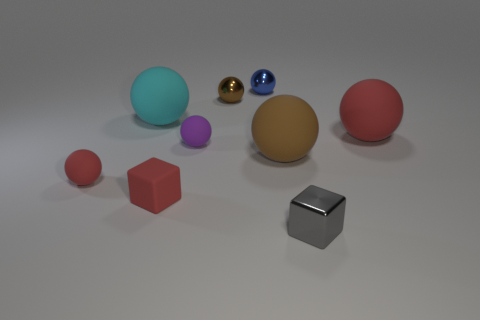There is a tiny red ball; are there any big red balls on the left side of it?
Provide a succinct answer. No. Is the number of small rubber objects that are behind the tiny brown sphere greater than the number of large red rubber objects that are left of the big cyan ball?
Provide a short and direct response. No. There is a cyan matte thing that is the same shape as the blue metallic thing; what size is it?
Offer a terse response. Large. What number of cylinders are rubber things or tiny blue things?
Your answer should be compact. 0. What is the material of the tiny thing that is the same color as the small matte block?
Give a very brief answer. Rubber. Are there fewer small purple spheres that are to the right of the small gray cube than matte blocks behind the red matte cube?
Your answer should be compact. No. How many things are tiny purple objects that are on the left side of the tiny blue ball or large cyan rubber cylinders?
Provide a short and direct response. 1. What is the shape of the large matte object that is behind the red rubber object on the right side of the large brown sphere?
Your response must be concise. Sphere. Is there a red sphere that has the same size as the blue shiny object?
Keep it short and to the point. Yes. Is the number of small blue metallic balls greater than the number of red rubber balls?
Provide a short and direct response. No. 